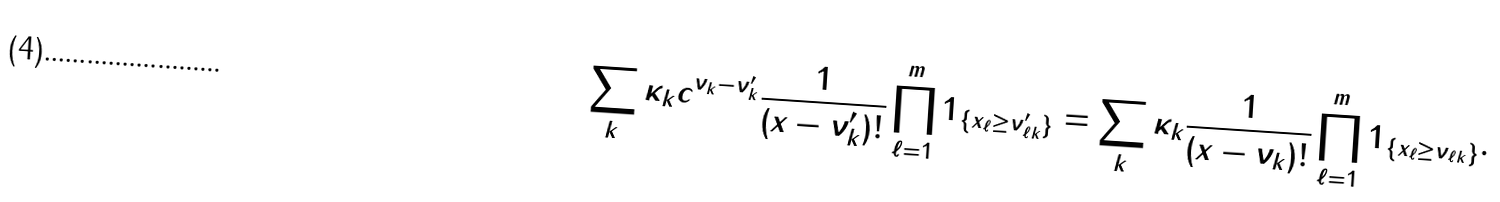<formula> <loc_0><loc_0><loc_500><loc_500>\sum _ { k } \kappa _ { k } c ^ { \nu _ { k } - \nu _ { k } ^ { \prime } } \frac { 1 } { ( x - \nu _ { k } ^ { \prime } ) ! } \prod _ { \ell = 1 } ^ { m } 1 _ { \{ x _ { \ell } \geq \nu _ { \ell k } ^ { \prime } \} } = \sum _ { k } \kappa _ { k } \frac { 1 } { ( x - \nu _ { k } ) ! } \prod _ { \ell = 1 } ^ { m } 1 _ { \{ x _ { \ell } \geq \nu _ { \ell k } \} } .</formula> 